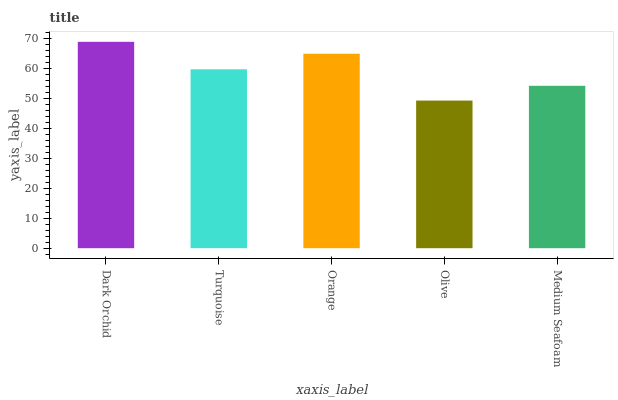Is Olive the minimum?
Answer yes or no. Yes. Is Dark Orchid the maximum?
Answer yes or no. Yes. Is Turquoise the minimum?
Answer yes or no. No. Is Turquoise the maximum?
Answer yes or no. No. Is Dark Orchid greater than Turquoise?
Answer yes or no. Yes. Is Turquoise less than Dark Orchid?
Answer yes or no. Yes. Is Turquoise greater than Dark Orchid?
Answer yes or no. No. Is Dark Orchid less than Turquoise?
Answer yes or no. No. Is Turquoise the high median?
Answer yes or no. Yes. Is Turquoise the low median?
Answer yes or no. Yes. Is Orange the high median?
Answer yes or no. No. Is Medium Seafoam the low median?
Answer yes or no. No. 